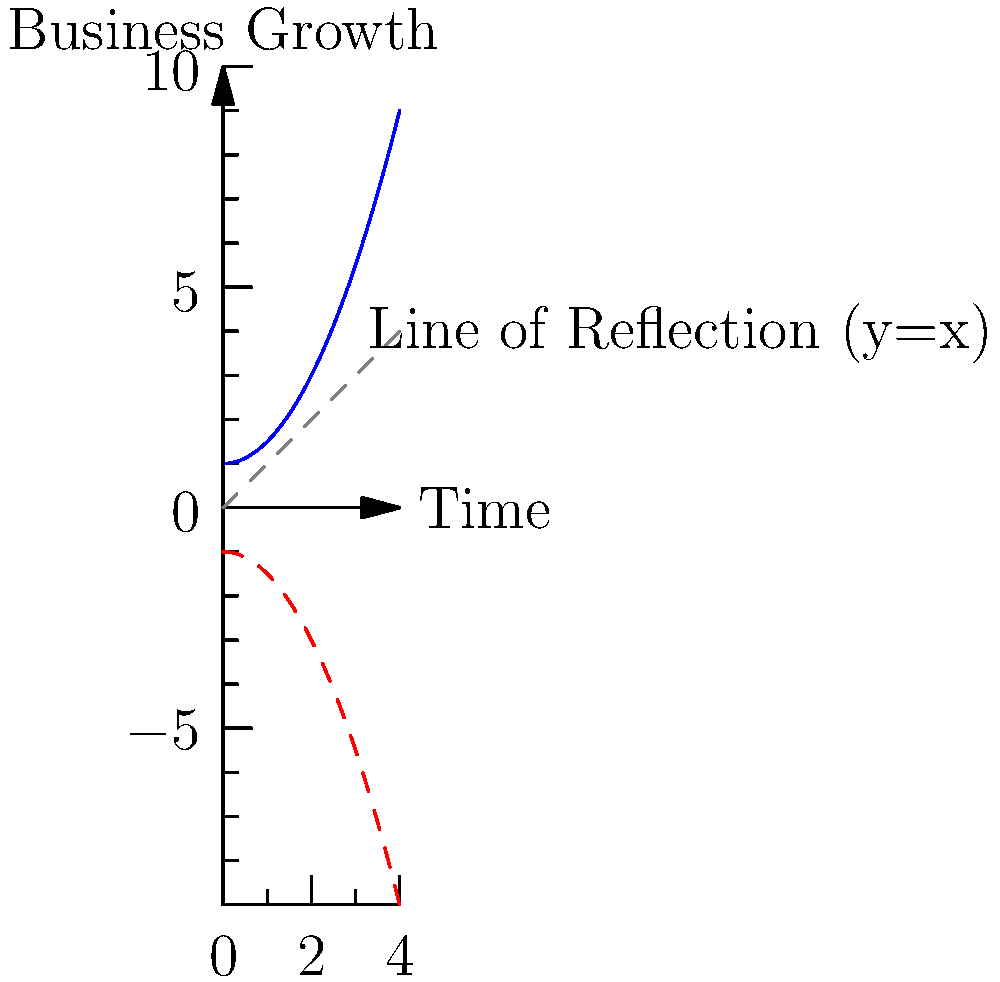The blue curve in the graph represents your business growth over time. To project future trends, you need to reflect this curve across the line $y=x$. What will be the equation of the reflected curve that represents the projected growth? To solve this problem, let's follow these steps:

1) The original function is of the form $f(x) = 0.5x^2 + 1$.

2) To reflect a function across the line $y=x$, we swap $x$ and $y$ in the original equation.

3) Start with $y = 0.5x^2 + 1$

4) Swap $x$ and $y$: $x = 0.5y^2 + 1$

5) Now, we need to solve this equation for $y$ to get it in the form $y = f(x)$:

   $x - 1 = 0.5y^2$
   $2(x - 1) = y^2$
   $y = \pm \sqrt{2(x - 1)}$

6) Since we're dealing with growth, we'll use the positive root:

   $y = \sqrt{2(x - 1)}$

7) This is the equation of the reflected curve.
Answer: $y = \sqrt{2(x - 1)}$ 